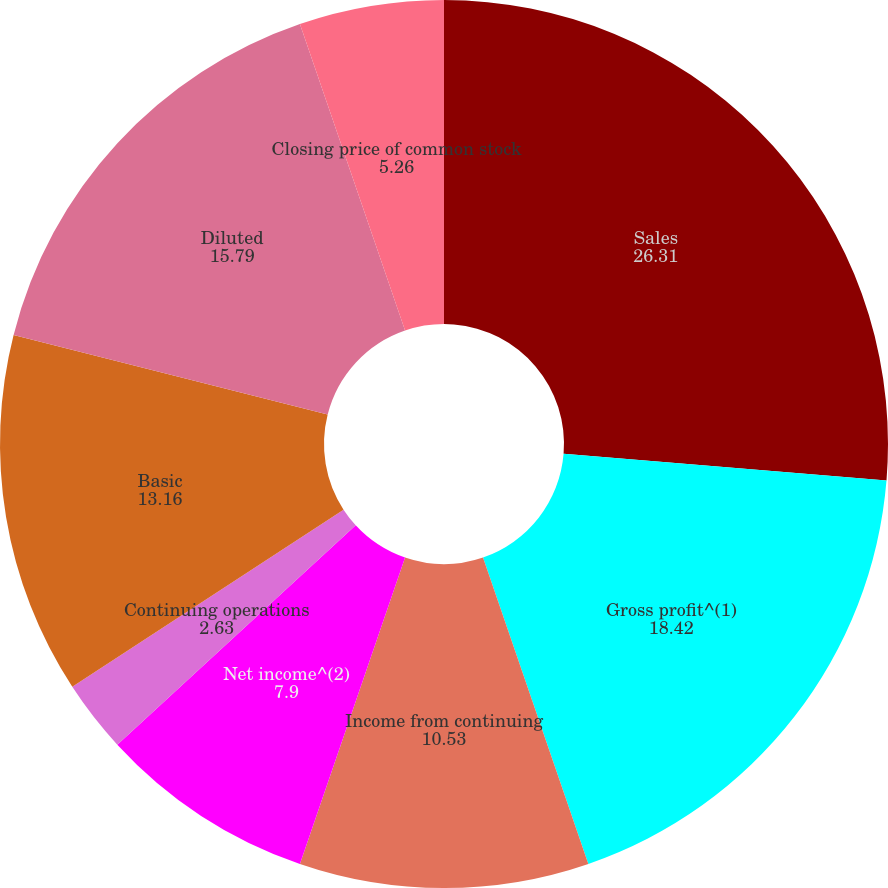Convert chart. <chart><loc_0><loc_0><loc_500><loc_500><pie_chart><fcel>Sales<fcel>Gross profit^(1)<fcel>Income from continuing<fcel>Net income^(2)<fcel>Continuing operations<fcel>Basic<fcel>Diluted<fcel>Cash dividends declared per<fcel>Closing price of common stock<nl><fcel>26.31%<fcel>18.42%<fcel>10.53%<fcel>7.9%<fcel>2.63%<fcel>13.16%<fcel>15.79%<fcel>0.0%<fcel>5.26%<nl></chart> 